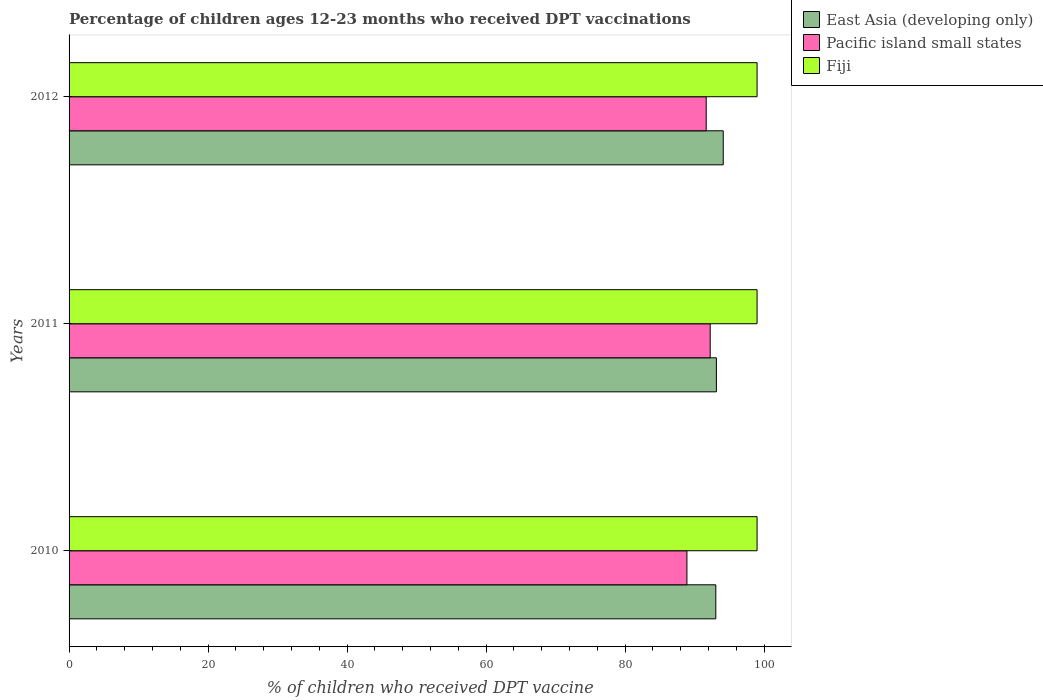Are the number of bars per tick equal to the number of legend labels?
Ensure brevity in your answer.  Yes. Are the number of bars on each tick of the Y-axis equal?
Your answer should be very brief. Yes. What is the label of the 2nd group of bars from the top?
Your response must be concise. 2011. What is the percentage of children who received DPT vaccination in Fiji in 2011?
Make the answer very short. 99. Across all years, what is the maximum percentage of children who received DPT vaccination in Pacific island small states?
Offer a very short reply. 92.26. Across all years, what is the minimum percentage of children who received DPT vaccination in Fiji?
Give a very brief answer. 99. What is the total percentage of children who received DPT vaccination in Fiji in the graph?
Offer a very short reply. 297. What is the difference between the percentage of children who received DPT vaccination in Pacific island small states in 2010 and that in 2012?
Keep it short and to the point. -2.78. What is the difference between the percentage of children who received DPT vaccination in Pacific island small states in 2011 and the percentage of children who received DPT vaccination in East Asia (developing only) in 2012?
Give a very brief answer. -1.88. What is the average percentage of children who received DPT vaccination in Pacific island small states per year?
Offer a very short reply. 90.95. In the year 2012, what is the difference between the percentage of children who received DPT vaccination in Pacific island small states and percentage of children who received DPT vaccination in East Asia (developing only)?
Your response must be concise. -2.45. What is the difference between the highest and the lowest percentage of children who received DPT vaccination in Pacific island small states?
Provide a short and direct response. 3.35. In how many years, is the percentage of children who received DPT vaccination in East Asia (developing only) greater than the average percentage of children who received DPT vaccination in East Asia (developing only) taken over all years?
Your answer should be very brief. 1. Is the sum of the percentage of children who received DPT vaccination in Pacific island small states in 2011 and 2012 greater than the maximum percentage of children who received DPT vaccination in East Asia (developing only) across all years?
Offer a very short reply. Yes. What does the 3rd bar from the top in 2010 represents?
Give a very brief answer. East Asia (developing only). What does the 2nd bar from the bottom in 2010 represents?
Keep it short and to the point. Pacific island small states. How many bars are there?
Give a very brief answer. 9. Are the values on the major ticks of X-axis written in scientific E-notation?
Offer a very short reply. No. Where does the legend appear in the graph?
Keep it short and to the point. Top right. How are the legend labels stacked?
Offer a very short reply. Vertical. What is the title of the graph?
Give a very brief answer. Percentage of children ages 12-23 months who received DPT vaccinations. Does "Dominica" appear as one of the legend labels in the graph?
Keep it short and to the point. No. What is the label or title of the X-axis?
Provide a succinct answer. % of children who received DPT vaccine. What is the label or title of the Y-axis?
Provide a succinct answer. Years. What is the % of children who received DPT vaccine of East Asia (developing only) in 2010?
Offer a very short reply. 93.06. What is the % of children who received DPT vaccine in Pacific island small states in 2010?
Offer a very short reply. 88.9. What is the % of children who received DPT vaccine of East Asia (developing only) in 2011?
Provide a short and direct response. 93.15. What is the % of children who received DPT vaccine in Pacific island small states in 2011?
Your answer should be very brief. 92.26. What is the % of children who received DPT vaccine of East Asia (developing only) in 2012?
Your response must be concise. 94.13. What is the % of children who received DPT vaccine of Pacific island small states in 2012?
Your answer should be compact. 91.68. Across all years, what is the maximum % of children who received DPT vaccine in East Asia (developing only)?
Keep it short and to the point. 94.13. Across all years, what is the maximum % of children who received DPT vaccine in Pacific island small states?
Give a very brief answer. 92.26. Across all years, what is the minimum % of children who received DPT vaccine of East Asia (developing only)?
Provide a short and direct response. 93.06. Across all years, what is the minimum % of children who received DPT vaccine in Pacific island small states?
Offer a terse response. 88.9. Across all years, what is the minimum % of children who received DPT vaccine in Fiji?
Your response must be concise. 99. What is the total % of children who received DPT vaccine in East Asia (developing only) in the graph?
Your response must be concise. 280.34. What is the total % of children who received DPT vaccine of Pacific island small states in the graph?
Your answer should be very brief. 272.84. What is the total % of children who received DPT vaccine in Fiji in the graph?
Your answer should be compact. 297. What is the difference between the % of children who received DPT vaccine in East Asia (developing only) in 2010 and that in 2011?
Offer a very short reply. -0.08. What is the difference between the % of children who received DPT vaccine of Pacific island small states in 2010 and that in 2011?
Offer a terse response. -3.35. What is the difference between the % of children who received DPT vaccine in East Asia (developing only) in 2010 and that in 2012?
Make the answer very short. -1.07. What is the difference between the % of children who received DPT vaccine of Pacific island small states in 2010 and that in 2012?
Make the answer very short. -2.78. What is the difference between the % of children who received DPT vaccine in East Asia (developing only) in 2011 and that in 2012?
Make the answer very short. -0.98. What is the difference between the % of children who received DPT vaccine in Pacific island small states in 2011 and that in 2012?
Your answer should be compact. 0.57. What is the difference between the % of children who received DPT vaccine of East Asia (developing only) in 2010 and the % of children who received DPT vaccine of Pacific island small states in 2011?
Offer a very short reply. 0.81. What is the difference between the % of children who received DPT vaccine of East Asia (developing only) in 2010 and the % of children who received DPT vaccine of Fiji in 2011?
Keep it short and to the point. -5.94. What is the difference between the % of children who received DPT vaccine in Pacific island small states in 2010 and the % of children who received DPT vaccine in Fiji in 2011?
Offer a terse response. -10.1. What is the difference between the % of children who received DPT vaccine in East Asia (developing only) in 2010 and the % of children who received DPT vaccine in Pacific island small states in 2012?
Provide a succinct answer. 1.38. What is the difference between the % of children who received DPT vaccine of East Asia (developing only) in 2010 and the % of children who received DPT vaccine of Fiji in 2012?
Give a very brief answer. -5.94. What is the difference between the % of children who received DPT vaccine of Pacific island small states in 2010 and the % of children who received DPT vaccine of Fiji in 2012?
Keep it short and to the point. -10.1. What is the difference between the % of children who received DPT vaccine of East Asia (developing only) in 2011 and the % of children who received DPT vaccine of Pacific island small states in 2012?
Ensure brevity in your answer.  1.47. What is the difference between the % of children who received DPT vaccine in East Asia (developing only) in 2011 and the % of children who received DPT vaccine in Fiji in 2012?
Your response must be concise. -5.85. What is the difference between the % of children who received DPT vaccine of Pacific island small states in 2011 and the % of children who received DPT vaccine of Fiji in 2012?
Keep it short and to the point. -6.74. What is the average % of children who received DPT vaccine in East Asia (developing only) per year?
Give a very brief answer. 93.45. What is the average % of children who received DPT vaccine of Pacific island small states per year?
Your response must be concise. 90.95. What is the average % of children who received DPT vaccine in Fiji per year?
Offer a very short reply. 99. In the year 2010, what is the difference between the % of children who received DPT vaccine of East Asia (developing only) and % of children who received DPT vaccine of Pacific island small states?
Your answer should be very brief. 4.16. In the year 2010, what is the difference between the % of children who received DPT vaccine in East Asia (developing only) and % of children who received DPT vaccine in Fiji?
Your response must be concise. -5.94. In the year 2010, what is the difference between the % of children who received DPT vaccine in Pacific island small states and % of children who received DPT vaccine in Fiji?
Make the answer very short. -10.1. In the year 2011, what is the difference between the % of children who received DPT vaccine of East Asia (developing only) and % of children who received DPT vaccine of Pacific island small states?
Provide a succinct answer. 0.89. In the year 2011, what is the difference between the % of children who received DPT vaccine of East Asia (developing only) and % of children who received DPT vaccine of Fiji?
Provide a succinct answer. -5.85. In the year 2011, what is the difference between the % of children who received DPT vaccine of Pacific island small states and % of children who received DPT vaccine of Fiji?
Provide a succinct answer. -6.74. In the year 2012, what is the difference between the % of children who received DPT vaccine in East Asia (developing only) and % of children who received DPT vaccine in Pacific island small states?
Provide a short and direct response. 2.45. In the year 2012, what is the difference between the % of children who received DPT vaccine of East Asia (developing only) and % of children who received DPT vaccine of Fiji?
Give a very brief answer. -4.87. In the year 2012, what is the difference between the % of children who received DPT vaccine of Pacific island small states and % of children who received DPT vaccine of Fiji?
Offer a very short reply. -7.32. What is the ratio of the % of children who received DPT vaccine of East Asia (developing only) in 2010 to that in 2011?
Provide a succinct answer. 1. What is the ratio of the % of children who received DPT vaccine in Pacific island small states in 2010 to that in 2011?
Make the answer very short. 0.96. What is the ratio of the % of children who received DPT vaccine in East Asia (developing only) in 2010 to that in 2012?
Offer a very short reply. 0.99. What is the ratio of the % of children who received DPT vaccine of Pacific island small states in 2010 to that in 2012?
Offer a terse response. 0.97. What is the ratio of the % of children who received DPT vaccine in Fiji in 2010 to that in 2012?
Provide a succinct answer. 1. What is the ratio of the % of children who received DPT vaccine of East Asia (developing only) in 2011 to that in 2012?
Your answer should be compact. 0.99. What is the ratio of the % of children who received DPT vaccine of Fiji in 2011 to that in 2012?
Provide a succinct answer. 1. What is the difference between the highest and the second highest % of children who received DPT vaccine in East Asia (developing only)?
Provide a succinct answer. 0.98. What is the difference between the highest and the second highest % of children who received DPT vaccine of Pacific island small states?
Your answer should be compact. 0.57. What is the difference between the highest and the lowest % of children who received DPT vaccine in East Asia (developing only)?
Your response must be concise. 1.07. What is the difference between the highest and the lowest % of children who received DPT vaccine of Pacific island small states?
Your response must be concise. 3.35. What is the difference between the highest and the lowest % of children who received DPT vaccine in Fiji?
Your response must be concise. 0. 